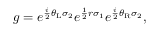<formula> <loc_0><loc_0><loc_500><loc_500>g = e ^ { \frac { i } { 2 } \theta _ { L } \sigma _ { 2 } } e ^ { \frac { 1 } { 2 } r \sigma _ { 1 } } e ^ { \frac { i } { 2 } \theta _ { R } \sigma _ { 2 } } ,</formula> 